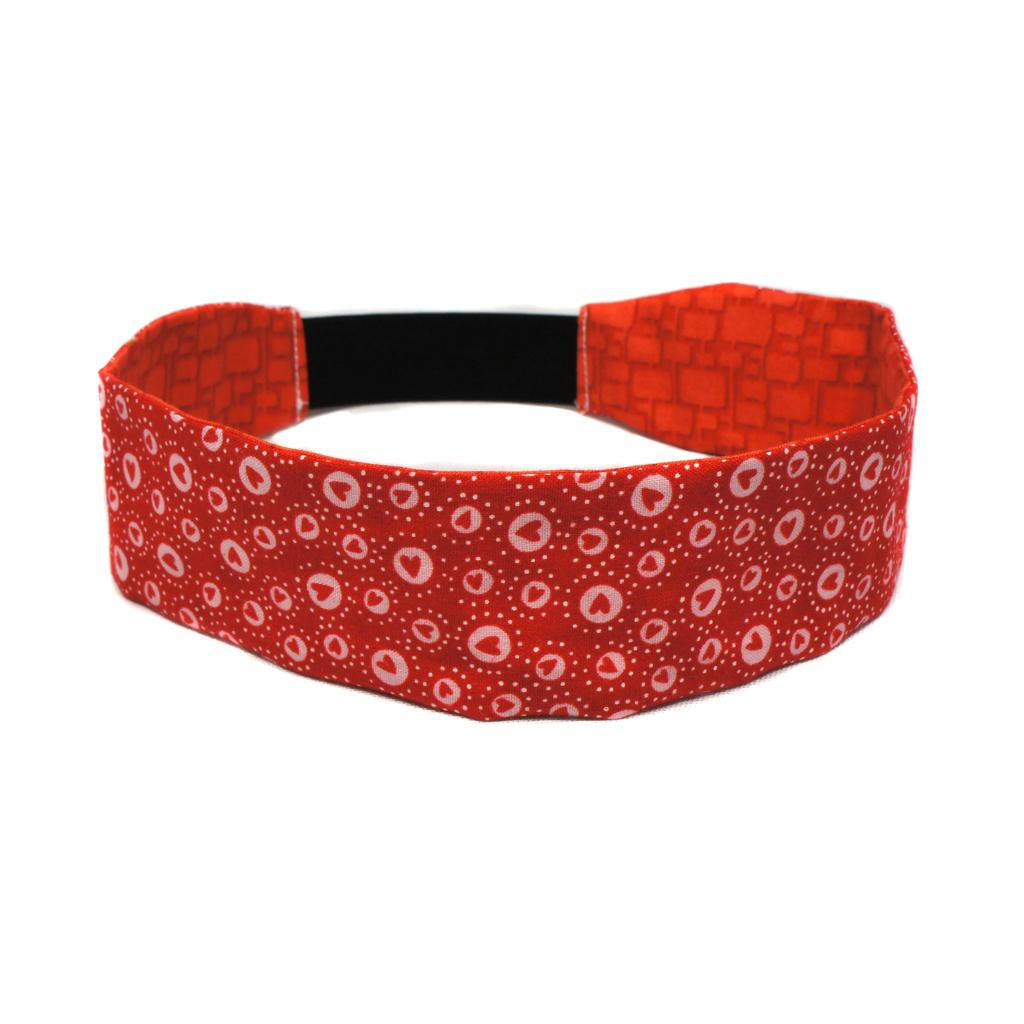What object in the image resembles a belt? There is an object that looks like a belt in the image. What color is the background of the image? The background of the image is white. How many potatoes can be seen in the image? There are no potatoes present in the image. What is the profit margin of the belt-like object in the image? There is no information about the profit margin of the belt-like object in the image. 